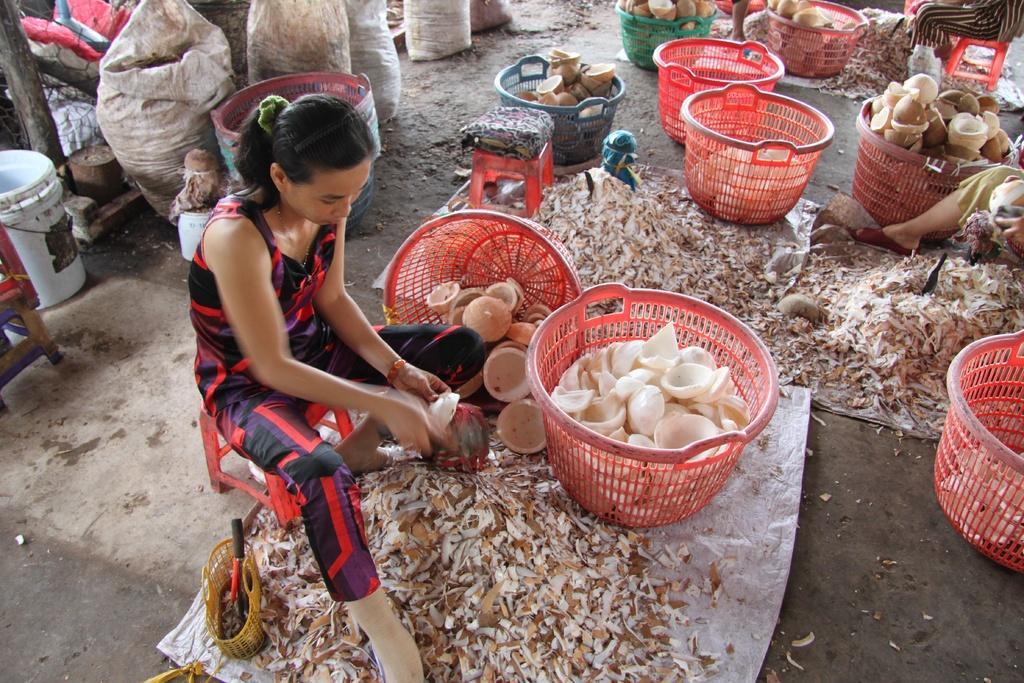In one or two sentences, can you explain what this image depicts? In this picture there is a women wearing a black and red color top, sitting on the table and cutting the coconuts. Beside there are many red color baskets full of coconut. In the background there are some white color bags and bucket. 